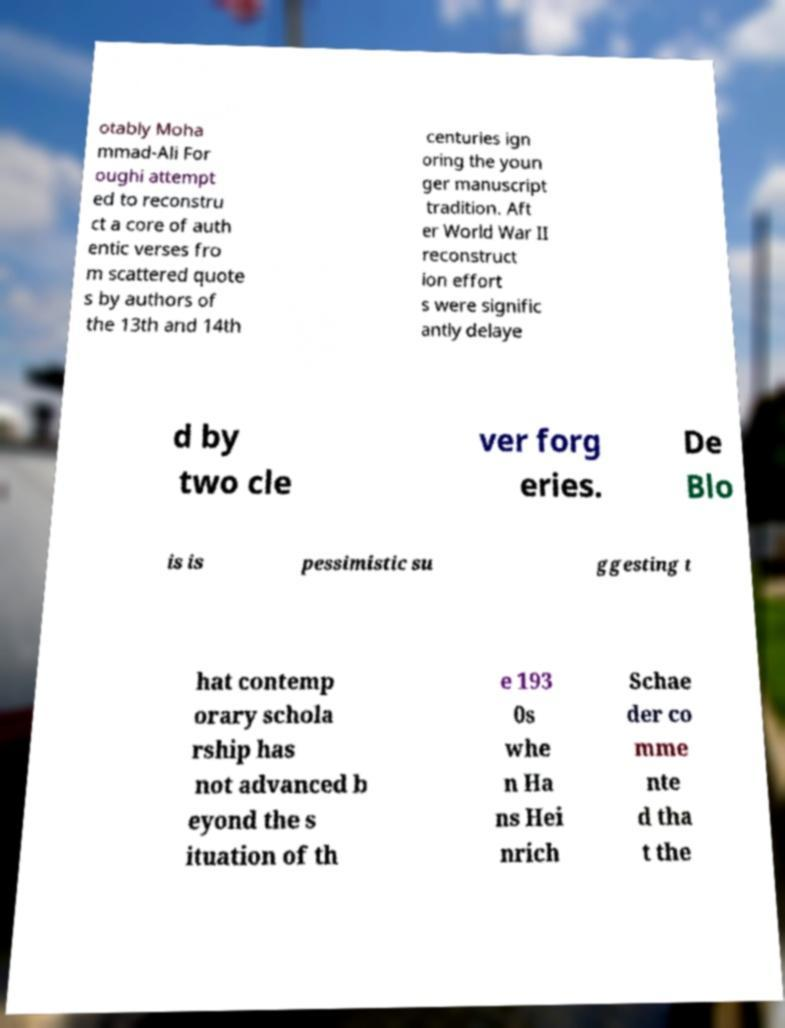Please identify and transcribe the text found in this image. otably Moha mmad-Ali For oughi attempt ed to reconstru ct a core of auth entic verses fro m scattered quote s by authors of the 13th and 14th centuries ign oring the youn ger manuscript tradition. Aft er World War II reconstruct ion effort s were signific antly delaye d by two cle ver forg eries. De Blo is is pessimistic su ggesting t hat contemp orary schola rship has not advanced b eyond the s ituation of th e 193 0s whe n Ha ns Hei nrich Schae der co mme nte d tha t the 